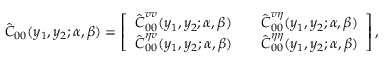<formula> <loc_0><loc_0><loc_500><loc_500>\hat { C } _ { 0 0 } ( y _ { 1 } , y _ { 2 } ; \alpha , \beta ) = \left [ \begin{array} { l l l } { \hat { C } _ { 0 0 } ^ { v v } ( y _ { 1 } , y _ { 2 } ; \alpha , \beta ) } & & { \hat { C } _ { 0 0 } ^ { v \eta } ( y _ { 1 } , y _ { 2 } ; \alpha , \beta ) } \\ { \hat { C } _ { 0 0 } ^ { \eta v } ( y _ { 1 } , y _ { 2 } ; \alpha , \beta ) } & & { \hat { C } _ { 0 0 } ^ { \eta \eta } ( y _ { 1 } , y _ { 2 } ; \alpha , \beta ) } \end{array} \right ] ,</formula> 